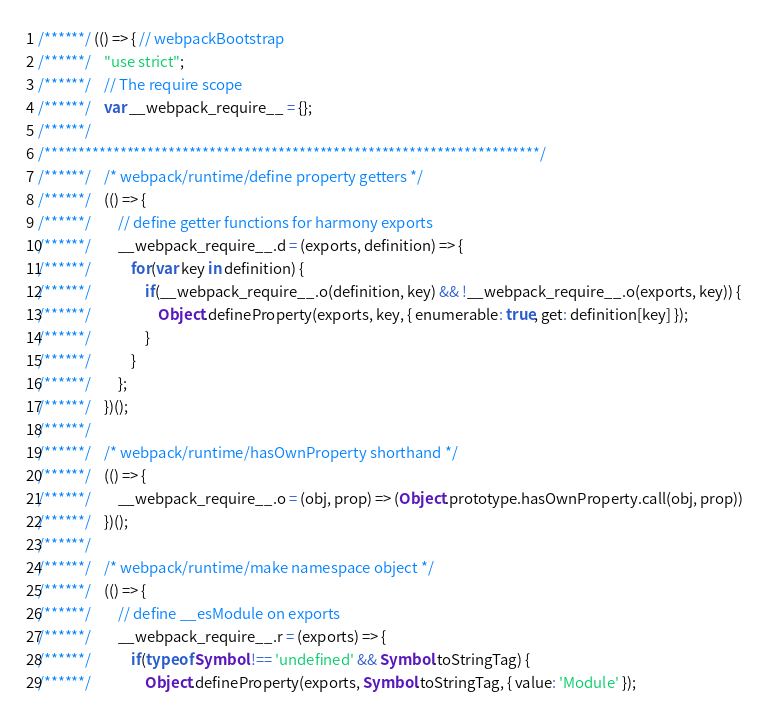<code> <loc_0><loc_0><loc_500><loc_500><_JavaScript_>/******/ (() => { // webpackBootstrap
/******/ 	"use strict";
/******/ 	// The require scope
/******/ 	var __webpack_require__ = {};
/******/ 	
/************************************************************************/
/******/ 	/* webpack/runtime/define property getters */
/******/ 	(() => {
/******/ 		// define getter functions for harmony exports
/******/ 		__webpack_require__.d = (exports, definition) => {
/******/ 			for(var key in definition) {
/******/ 				if(__webpack_require__.o(definition, key) && !__webpack_require__.o(exports, key)) {
/******/ 					Object.defineProperty(exports, key, { enumerable: true, get: definition[key] });
/******/ 				}
/******/ 			}
/******/ 		};
/******/ 	})();
/******/ 	
/******/ 	/* webpack/runtime/hasOwnProperty shorthand */
/******/ 	(() => {
/******/ 		__webpack_require__.o = (obj, prop) => (Object.prototype.hasOwnProperty.call(obj, prop))
/******/ 	})();
/******/ 	
/******/ 	/* webpack/runtime/make namespace object */
/******/ 	(() => {
/******/ 		// define __esModule on exports
/******/ 		__webpack_require__.r = (exports) => {
/******/ 			if(typeof Symbol !== 'undefined' && Symbol.toStringTag) {
/******/ 				Object.defineProperty(exports, Symbol.toStringTag, { value: 'Module' });</code> 